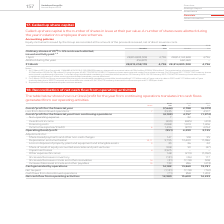According to Vodafone Group Plc's financial document, What does the table below show? how our (loss)/profit for the year from continuing operations translates into cash flows generated from our operating activities. The document states: "The table below shows how our (loss)/profit for the year from continuing operations translates into cash flows generated from our operating activities..." Also, How much is the 2019 net tax? According to the financial document, 1,131 (in millions). The relevant text states: "by operations 14,182 13,860 13,781 Net tax paid (1,131) (1,118) (761) Cash flows from discontinued operations (71) 858 1,203 Net cash flow from operating..." Also, How much is the 2018 net tax paid? According to the financial document, 1,118 (in millions). The relevant text states: "/decrease in trade and other receivables 14 (31) (1,118) 308 Increase/(decrease) in trade and other payables 15 739 286 (473) Cash generated by operations..." Also, can you calculate: What is the average net cash flow from operating activities between 2018 and 2019? To answer this question, I need to perform calculations using the financial data. The calculation is: (12,980+13,600)/2, which equals 13290 (in millions). This is based on the information: "858 1,203 Net cash flow from operating activities 12,980 13,600 14,223 03 Net cash flow from operating activities 12,980 13,600 14,223..." The key data points involved are: 12,980, 13,600. Also, can you calculate: What is the average net cash flow from operating activities between 2017 and 2018? To answer this question, I need to perform calculations using the financial data. The calculation is: (13,600+14,223)/2, which equals 13911.5 (in millions). This is based on the information: "cash flow from operating activities 12,980 13,600 14,223 03 Net cash flow from operating activities 12,980 13,600 14,223..." The key data points involved are: 13,600, 14,223. Also, can you calculate: What is the change of average net cash flow from operating activities between 2017-2018 and 2018-2019? To answer this question, I need to perform calculations using the financial data. The calculation is: [(12,980+13,600)/2] - [(13,600+14,223)/2], which equals -621.5 (in millions). This is based on the information: "858 1,203 Net cash flow from operating activities 12,980 13,600 14,223 858 1,203 Net cash flow from operating activities 12,980 13,600 14,223 cash flow from operating activities 12,980 13,600 14,223 0..." The key data points involved are: 12,980, 13,600, 14,223. 